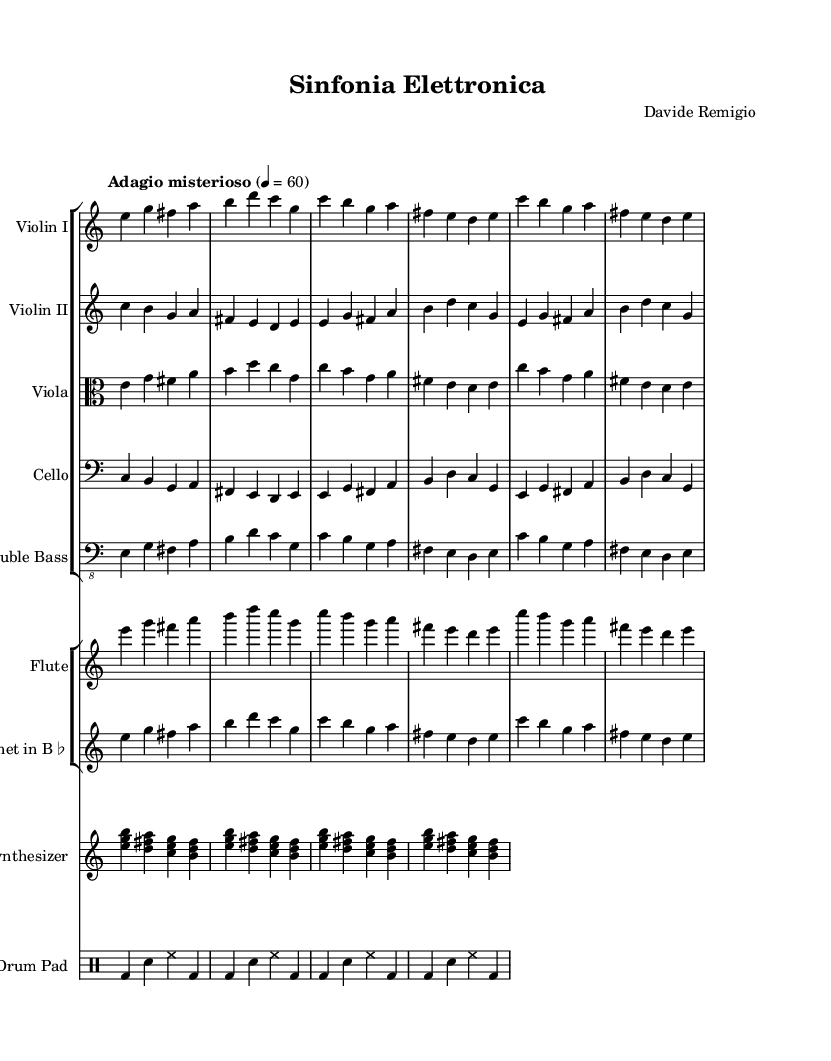What is the time signature of this composition? The time signature is indicated as 4/4 throughout the piece, which means there are four beats in each measure, and the quarter note gets one beat.
Answer: 4/4 What is the tempo marking for the music? The tempo marking is "Adagio misterioso", which suggests a slow and mysterious performance speed. The written metronome mark is 60 beats per minute.
Answer: Adagio misterioso How many instruments are included in the orchestration? The score contains seven distinct instruments, including strings, woodwinds, a synthesizer, and an electronic drum pad.
Answer: Seven Which instrument plays a synthesizer part? The synthesizer part is specifically written for the staff labeled "Synthesizer" which includes chords represented with multiple voices.
Answer: Synthesizer What unique elements differentiate this composition as an experimental work? The incorporation of both traditional orchestration (like strings and woodwinds) and electronic elements (synthesizer and electronic drum pad) exemplifies the blend of acoustic and electronic music, a hallmark of experimental composition.
Answer: Traditional and electronic elements How does the viola's melody compare to the violin parts? The viola plays a melody that mirrors the violin parts in rhythm and pulse, but it has its own distinct notes especially in the first measure, showcasing a thoughtful interplay between voices.
Answer: Interplay of voices What type of synthesizer notation is used in the score? The synthesizer uses a chord-based notation with multiple notes played simultaneously, indicating a harmonic texture rather than a single melodic line.
Answer: Chord-based notation 